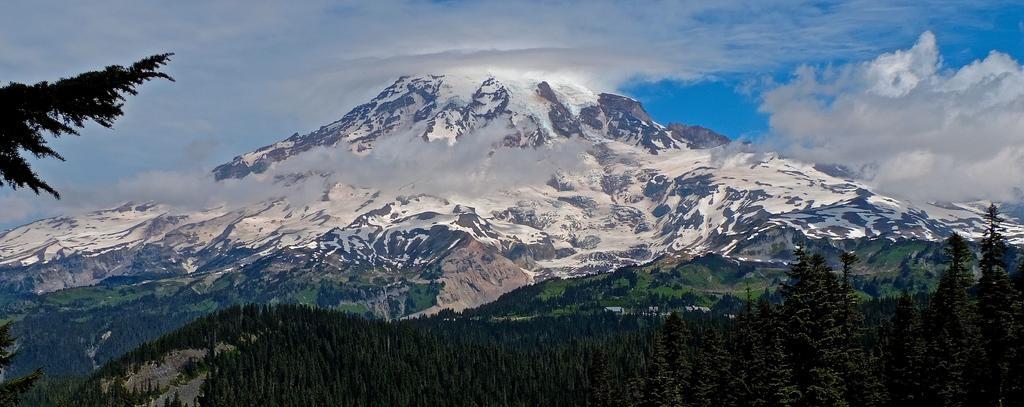In one or two sentences, can you explain what this image depicts? This image consists of mountains. There are trees at the bottom. There is sky at the top. 